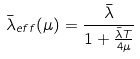Convert formula to latex. <formula><loc_0><loc_0><loc_500><loc_500>\bar { \lambda } _ { e f f } ( \mu ) = \frac { \bar { \lambda } } { 1 + \frac { \bar { \lambda } T } { 4 \mu } }</formula> 